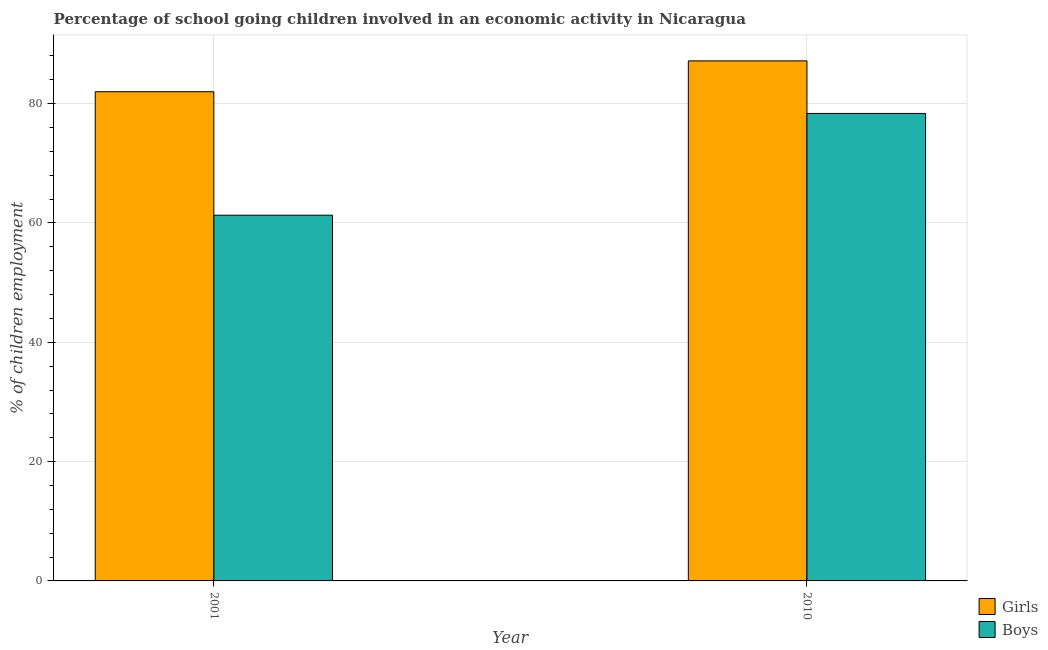Are the number of bars per tick equal to the number of legend labels?
Provide a succinct answer. Yes. Are the number of bars on each tick of the X-axis equal?
Keep it short and to the point. Yes. How many bars are there on the 2nd tick from the left?
Give a very brief answer. 2. How many bars are there on the 1st tick from the right?
Your answer should be very brief. 2. What is the percentage of school going girls in 2001?
Your answer should be compact. 81.99. Across all years, what is the maximum percentage of school going girls?
Offer a terse response. 87.16. Across all years, what is the minimum percentage of school going boys?
Your response must be concise. 61.3. In which year was the percentage of school going girls minimum?
Provide a succinct answer. 2001. What is the total percentage of school going boys in the graph?
Your answer should be very brief. 139.65. What is the difference between the percentage of school going girls in 2001 and that in 2010?
Give a very brief answer. -5.17. What is the difference between the percentage of school going boys in 2001 and the percentage of school going girls in 2010?
Offer a terse response. -17.06. What is the average percentage of school going girls per year?
Offer a very short reply. 84.58. In how many years, is the percentage of school going girls greater than 80 %?
Give a very brief answer. 2. What is the ratio of the percentage of school going girls in 2001 to that in 2010?
Ensure brevity in your answer.  0.94. Is the percentage of school going girls in 2001 less than that in 2010?
Your answer should be compact. Yes. What does the 1st bar from the left in 2010 represents?
Give a very brief answer. Girls. What does the 2nd bar from the right in 2010 represents?
Ensure brevity in your answer.  Girls. How many bars are there?
Offer a terse response. 4. How many years are there in the graph?
Provide a short and direct response. 2. What is the difference between two consecutive major ticks on the Y-axis?
Your answer should be very brief. 20. Are the values on the major ticks of Y-axis written in scientific E-notation?
Ensure brevity in your answer.  No. Does the graph contain grids?
Provide a succinct answer. Yes. How many legend labels are there?
Ensure brevity in your answer.  2. How are the legend labels stacked?
Provide a succinct answer. Vertical. What is the title of the graph?
Your answer should be very brief. Percentage of school going children involved in an economic activity in Nicaragua. Does "Personal remittances" appear as one of the legend labels in the graph?
Offer a terse response. No. What is the label or title of the Y-axis?
Provide a succinct answer. % of children employment. What is the % of children employment of Girls in 2001?
Offer a terse response. 81.99. What is the % of children employment in Boys in 2001?
Your response must be concise. 61.3. What is the % of children employment in Girls in 2010?
Give a very brief answer. 87.16. What is the % of children employment in Boys in 2010?
Ensure brevity in your answer.  78.36. Across all years, what is the maximum % of children employment of Girls?
Provide a succinct answer. 87.16. Across all years, what is the maximum % of children employment in Boys?
Give a very brief answer. 78.36. Across all years, what is the minimum % of children employment in Girls?
Ensure brevity in your answer.  81.99. Across all years, what is the minimum % of children employment of Boys?
Ensure brevity in your answer.  61.3. What is the total % of children employment in Girls in the graph?
Offer a very short reply. 169.16. What is the total % of children employment of Boys in the graph?
Provide a short and direct response. 139.65. What is the difference between the % of children employment of Girls in 2001 and that in 2010?
Ensure brevity in your answer.  -5.17. What is the difference between the % of children employment in Boys in 2001 and that in 2010?
Give a very brief answer. -17.06. What is the difference between the % of children employment of Girls in 2001 and the % of children employment of Boys in 2010?
Provide a short and direct response. 3.64. What is the average % of children employment of Girls per year?
Your response must be concise. 84.58. What is the average % of children employment in Boys per year?
Give a very brief answer. 69.83. In the year 2001, what is the difference between the % of children employment of Girls and % of children employment of Boys?
Provide a succinct answer. 20.7. In the year 2010, what is the difference between the % of children employment of Girls and % of children employment of Boys?
Offer a terse response. 8.81. What is the ratio of the % of children employment of Girls in 2001 to that in 2010?
Provide a short and direct response. 0.94. What is the ratio of the % of children employment of Boys in 2001 to that in 2010?
Provide a succinct answer. 0.78. What is the difference between the highest and the second highest % of children employment in Girls?
Your response must be concise. 5.17. What is the difference between the highest and the second highest % of children employment in Boys?
Provide a succinct answer. 17.06. What is the difference between the highest and the lowest % of children employment of Girls?
Your answer should be compact. 5.17. What is the difference between the highest and the lowest % of children employment of Boys?
Your response must be concise. 17.06. 